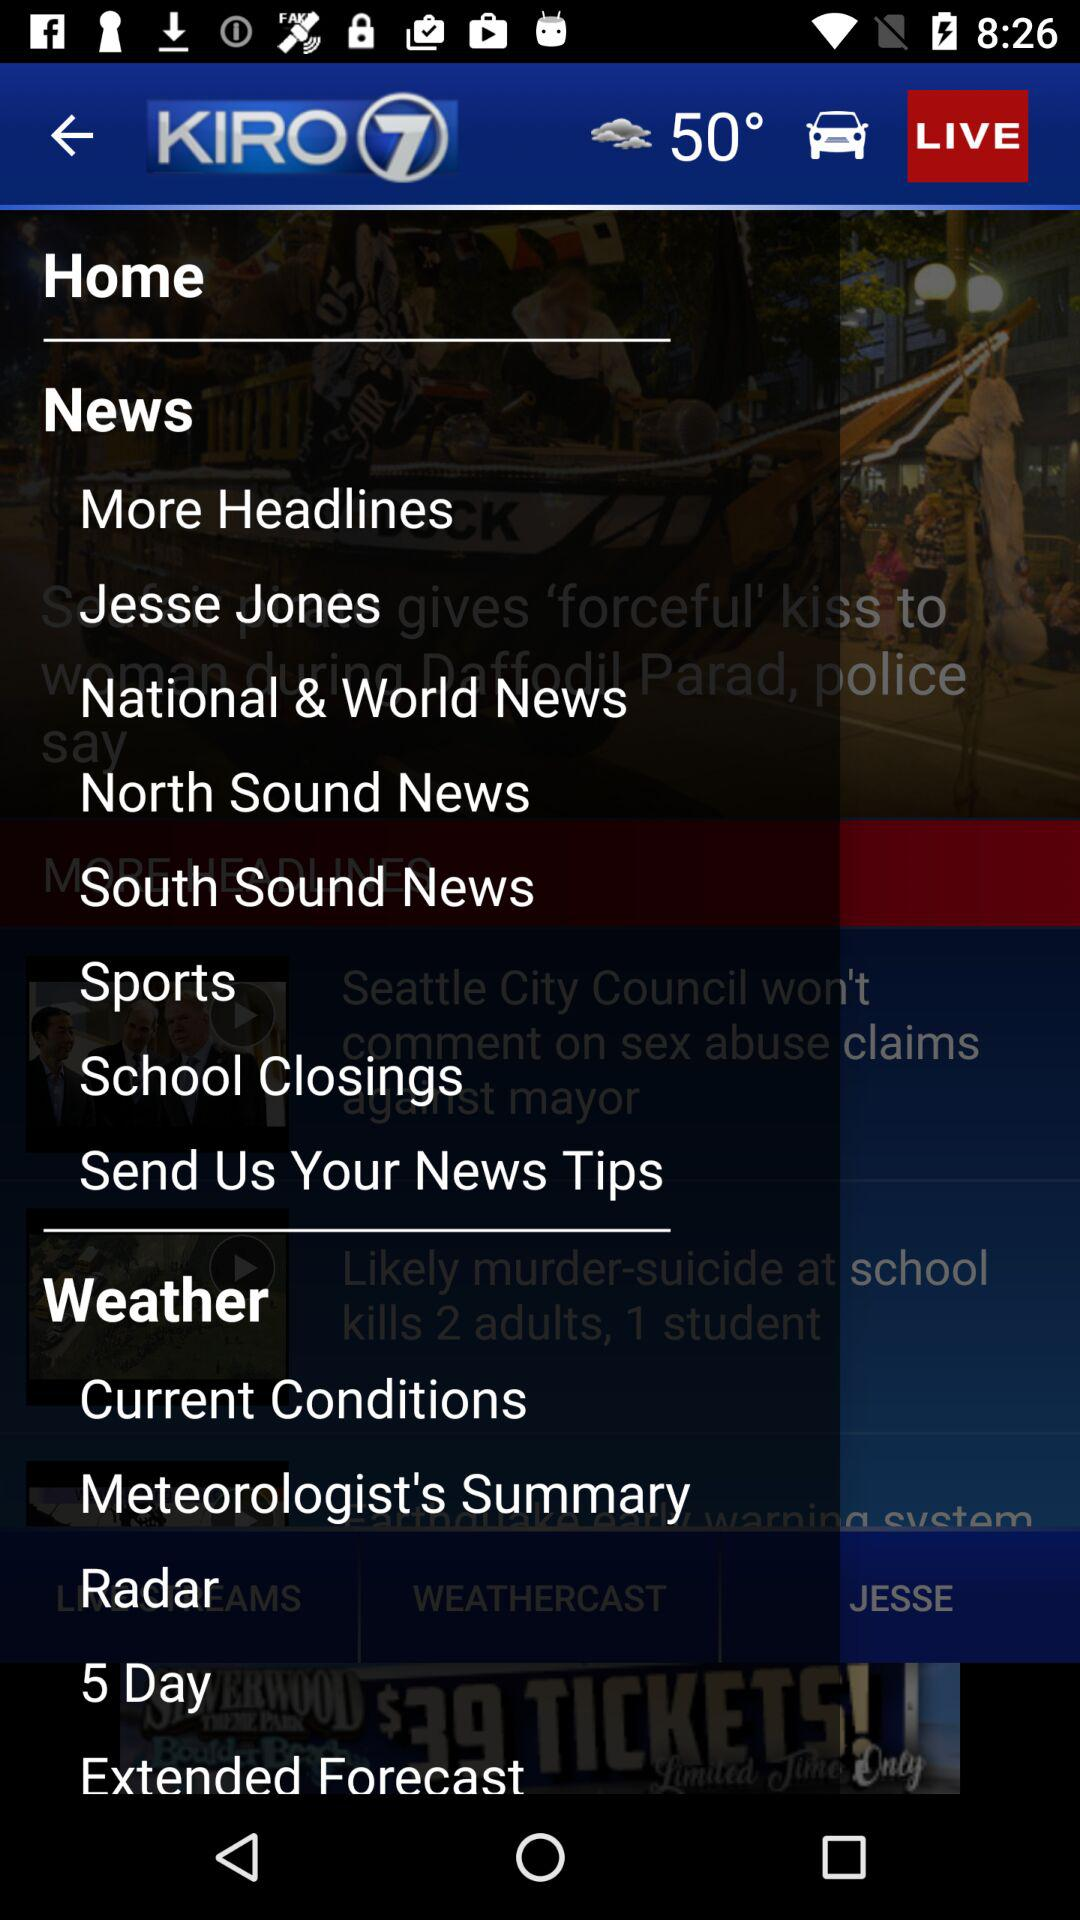What is the temperature? The temperature is 50°. 